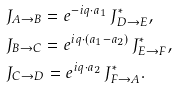<formula> <loc_0><loc_0><loc_500><loc_500>& J _ { A \to B } = e ^ { - i { q } \cdot { a } _ { 1 } } \, J ^ { * } _ { D \to E } , \\ & J _ { B \to C } = e ^ { i { q } \cdot ( { a } _ { 1 } - { a } _ { 2 } ) } \, J ^ { * } _ { E \to F } , \\ & J _ { C \to D } = e ^ { i { q } \cdot { a } _ { 2 } } \, J ^ { * } _ { F \to A } .</formula> 